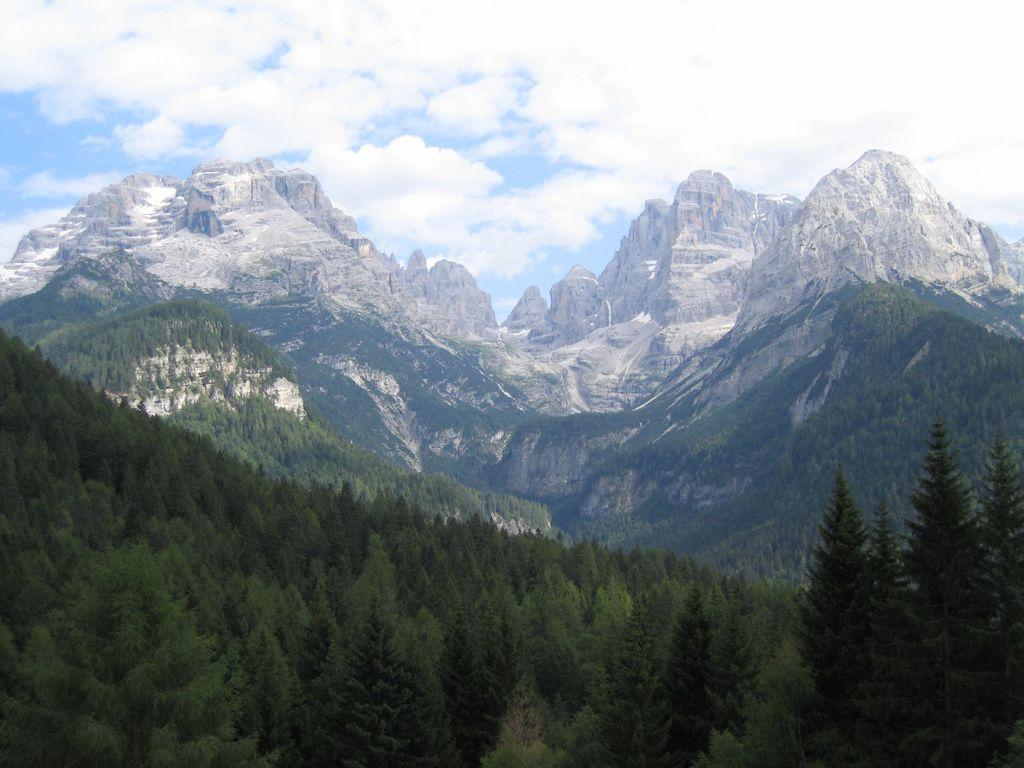What type of vegetation can be seen at the bottom of the image? There are trees in the front bottom side of the image. What geographical feature is located behind the trees? There are huge mountains behind the trees. What is visible at the top of the image? The sky is visible at the top of the image. What can be seen in the sky in the image? Clouds are present in the sky. Where is the tent located in the image? There is no tent present in the image. What type of exchange is taking place between the clouds and the mountains in the image? There is no exchange between the clouds and the mountains in the image; they are separate elements in the scene. 